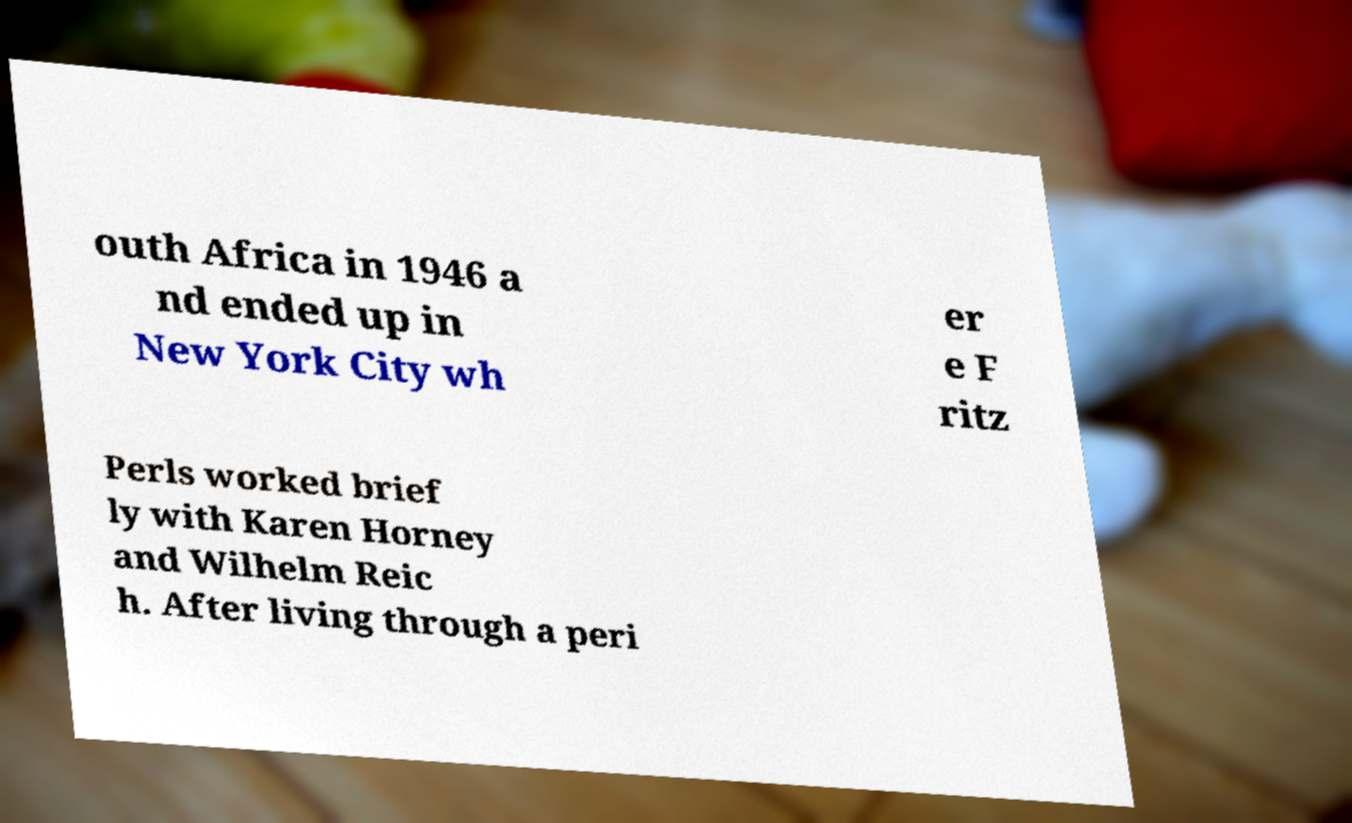For documentation purposes, I need the text within this image transcribed. Could you provide that? outh Africa in 1946 a nd ended up in New York City wh er e F ritz Perls worked brief ly with Karen Horney and Wilhelm Reic h. After living through a peri 